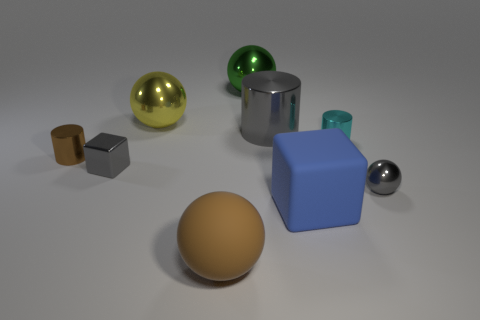Add 1 large spheres. How many objects exist? 10 Subtract all tiny cyan cylinders. How many cylinders are left? 2 Subtract 1 cylinders. How many cylinders are left? 2 Subtract all brown cylinders. How many cylinders are left? 2 Subtract 1 green balls. How many objects are left? 8 Subtract all spheres. How many objects are left? 5 Subtract all blue cubes. Subtract all cyan spheres. How many cubes are left? 1 Subtract all purple cylinders. How many blue spheres are left? 0 Subtract all gray spheres. Subtract all gray shiny balls. How many objects are left? 7 Add 6 small shiny objects. How many small shiny objects are left? 10 